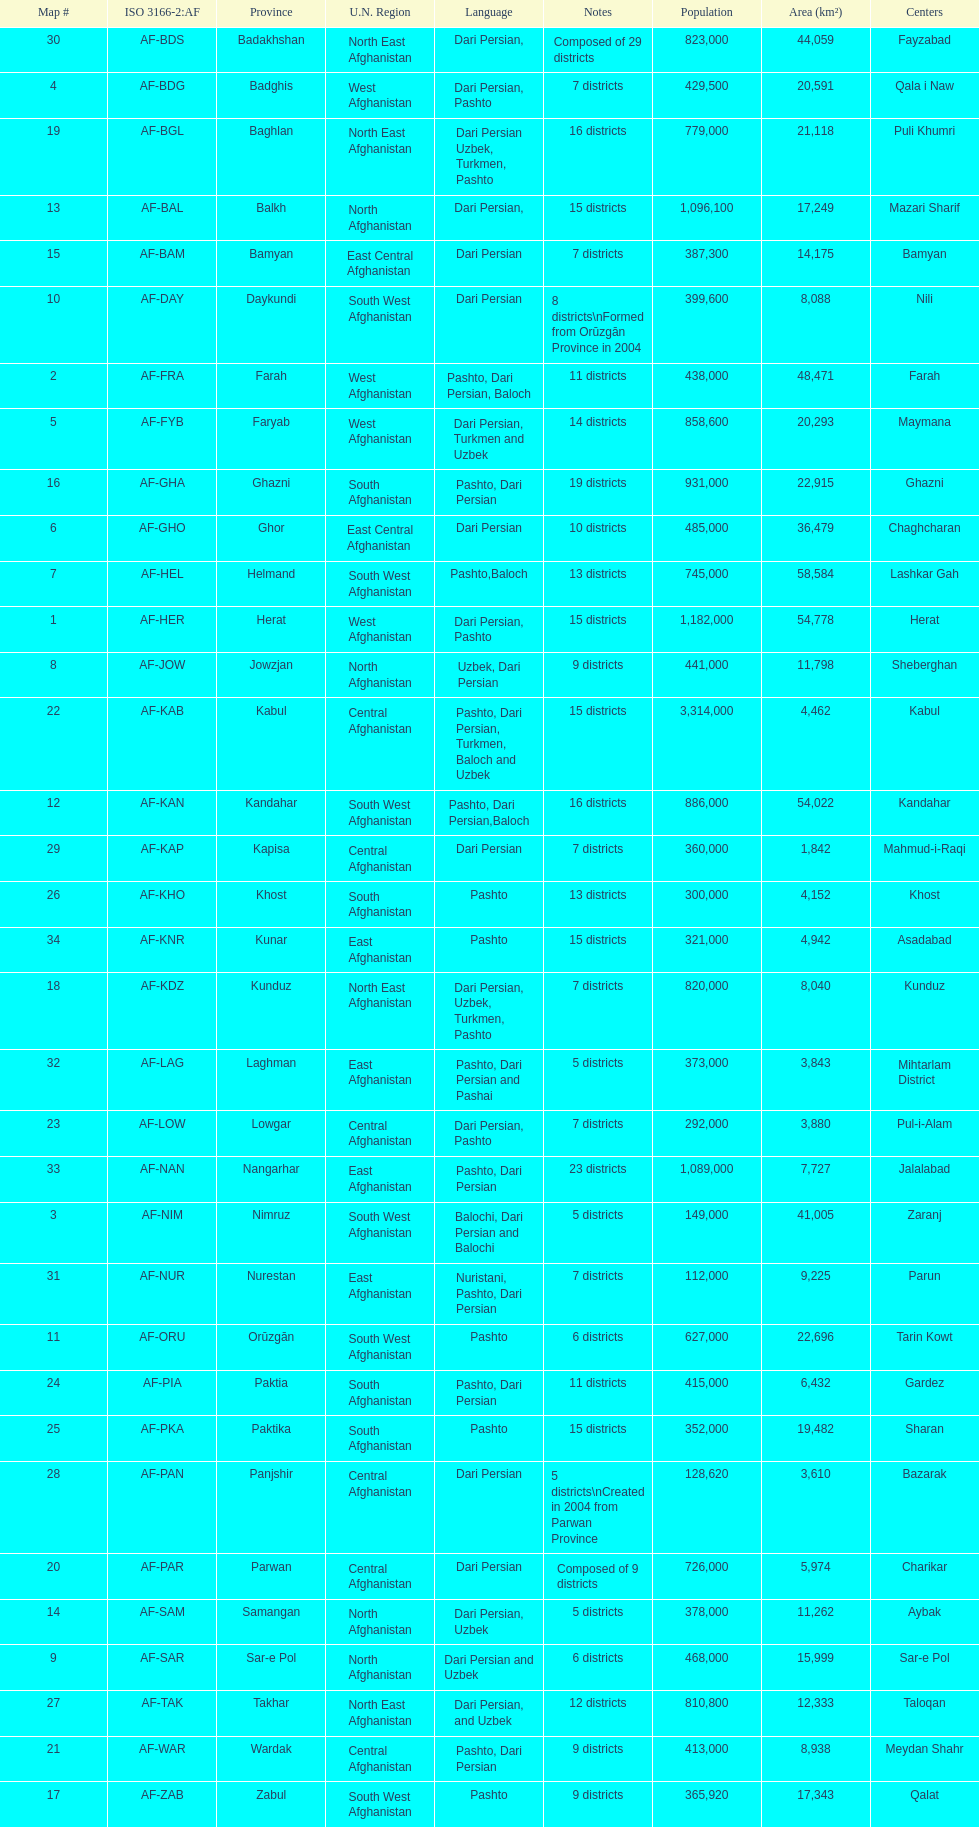How many provinces have the same number of districts as kabul? 4. 